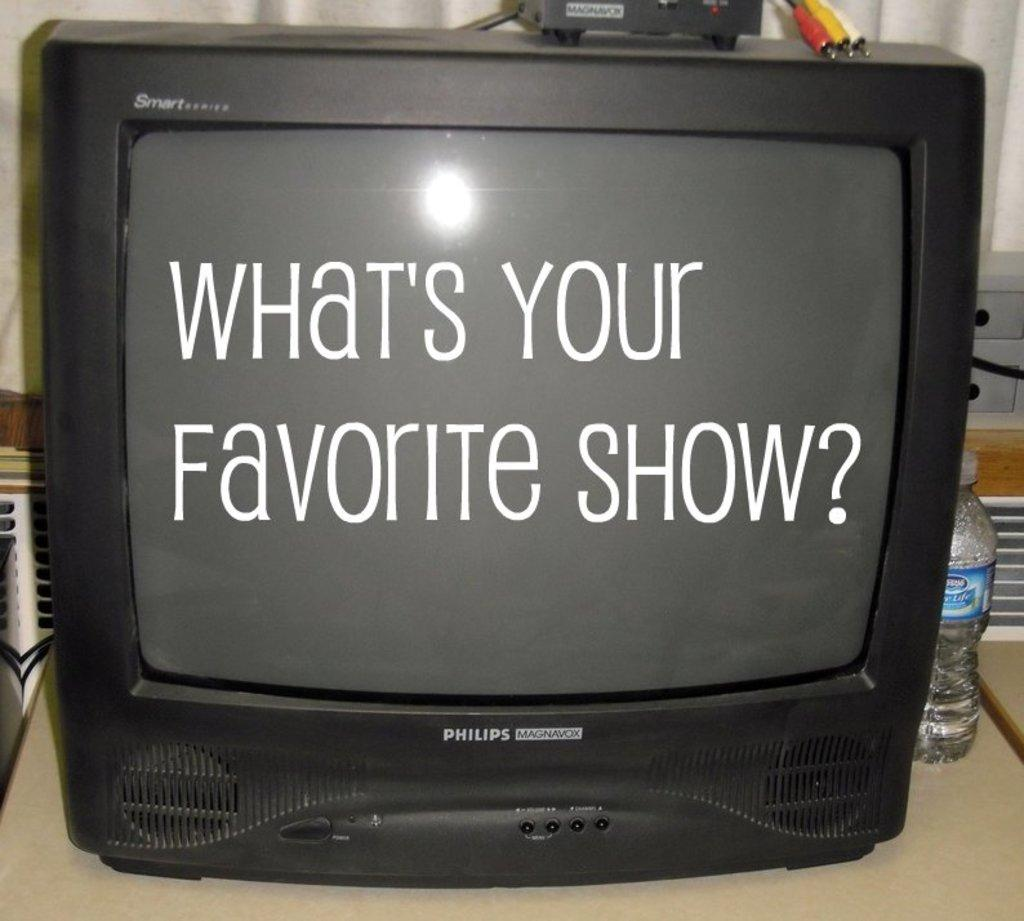Provide a one-sentence caption for the provided image. black tube tv screen that reads whats your favorite show? and a bottle of water necxt to it. 